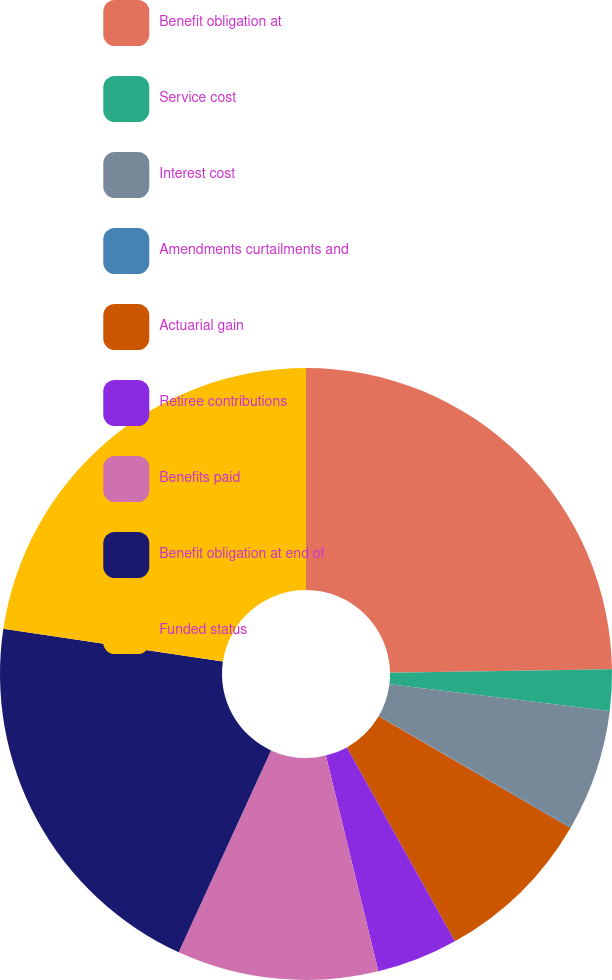Convert chart to OTSL. <chart><loc_0><loc_0><loc_500><loc_500><pie_chart><fcel>Benefit obligation at<fcel>Service cost<fcel>Interest cost<fcel>Amendments curtailments and<fcel>Actuarial gain<fcel>Retiree contributions<fcel>Benefits paid<fcel>Benefit obligation at end of<fcel>Funded status<nl><fcel>24.75%<fcel>2.18%<fcel>6.4%<fcel>0.06%<fcel>8.52%<fcel>4.29%<fcel>10.63%<fcel>20.53%<fcel>22.64%<nl></chart> 